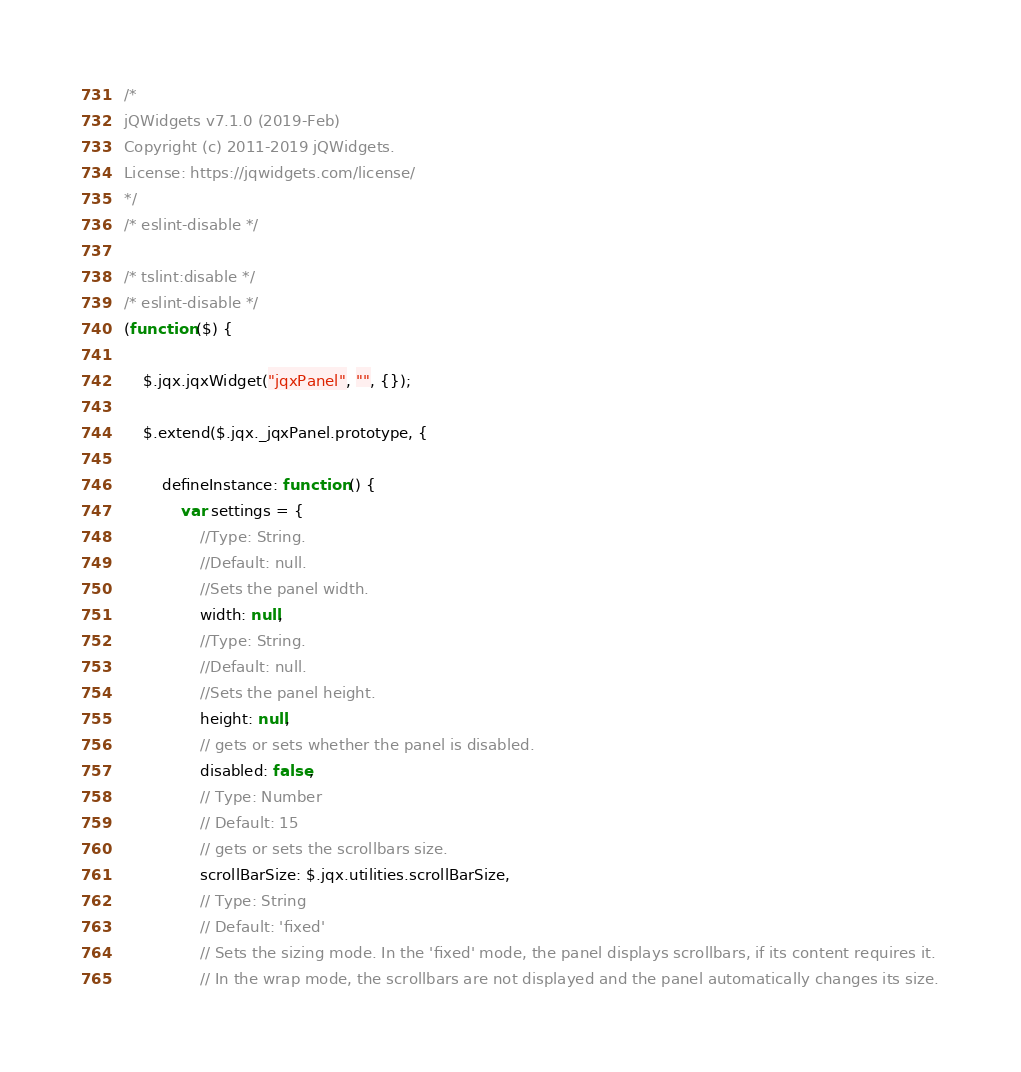Convert code to text. <code><loc_0><loc_0><loc_500><loc_500><_JavaScript_>/*
jQWidgets v7.1.0 (2019-Feb)
Copyright (c) 2011-2019 jQWidgets.
License: https://jqwidgets.com/license/
*/
/* eslint-disable */

/* tslint:disable */
/* eslint-disable */
(function ($) {

    $.jqx.jqxWidget("jqxPanel", "", {});

    $.extend($.jqx._jqxPanel.prototype, {

        defineInstance: function () {
            var settings = {
                //Type: String.
                //Default: null.
                //Sets the panel width.
                width: null,
                //Type: String.
                //Default: null.
                //Sets the panel height.
                height: null,
                // gets or sets whether the panel is disabled.
                disabled: false,
                // Type: Number
                // Default: 15
                // gets or sets the scrollbars size.
                scrollBarSize: $.jqx.utilities.scrollBarSize,
                // Type: String
                // Default: 'fixed'
                // Sets the sizing mode. In the 'fixed' mode, the panel displays scrollbars, if its content requires it. 
                // In the wrap mode, the scrollbars are not displayed and the panel automatically changes its size.</code> 